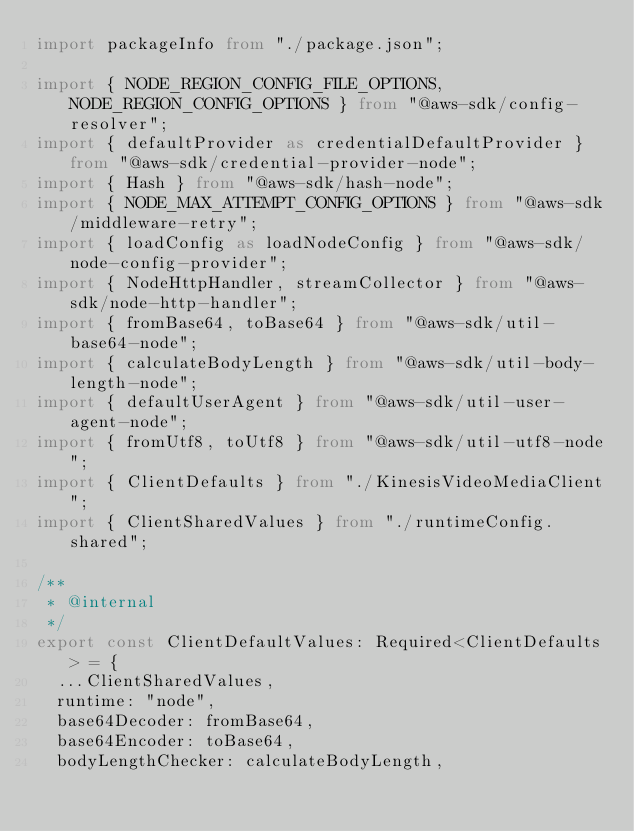Convert code to text. <code><loc_0><loc_0><loc_500><loc_500><_TypeScript_>import packageInfo from "./package.json";

import { NODE_REGION_CONFIG_FILE_OPTIONS, NODE_REGION_CONFIG_OPTIONS } from "@aws-sdk/config-resolver";
import { defaultProvider as credentialDefaultProvider } from "@aws-sdk/credential-provider-node";
import { Hash } from "@aws-sdk/hash-node";
import { NODE_MAX_ATTEMPT_CONFIG_OPTIONS } from "@aws-sdk/middleware-retry";
import { loadConfig as loadNodeConfig } from "@aws-sdk/node-config-provider";
import { NodeHttpHandler, streamCollector } from "@aws-sdk/node-http-handler";
import { fromBase64, toBase64 } from "@aws-sdk/util-base64-node";
import { calculateBodyLength } from "@aws-sdk/util-body-length-node";
import { defaultUserAgent } from "@aws-sdk/util-user-agent-node";
import { fromUtf8, toUtf8 } from "@aws-sdk/util-utf8-node";
import { ClientDefaults } from "./KinesisVideoMediaClient";
import { ClientSharedValues } from "./runtimeConfig.shared";

/**
 * @internal
 */
export const ClientDefaultValues: Required<ClientDefaults> = {
  ...ClientSharedValues,
  runtime: "node",
  base64Decoder: fromBase64,
  base64Encoder: toBase64,
  bodyLengthChecker: calculateBodyLength,</code> 